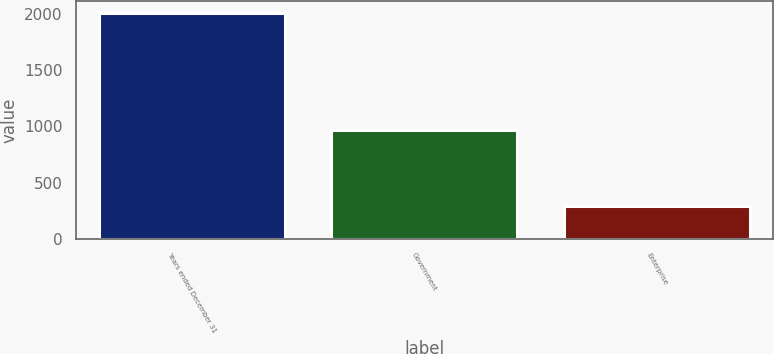Convert chart to OTSL. <chart><loc_0><loc_0><loc_500><loc_500><bar_chart><fcel>Years ended December 31<fcel>Government<fcel>Enterprise<nl><fcel>2012<fcel>965<fcel>291<nl></chart> 